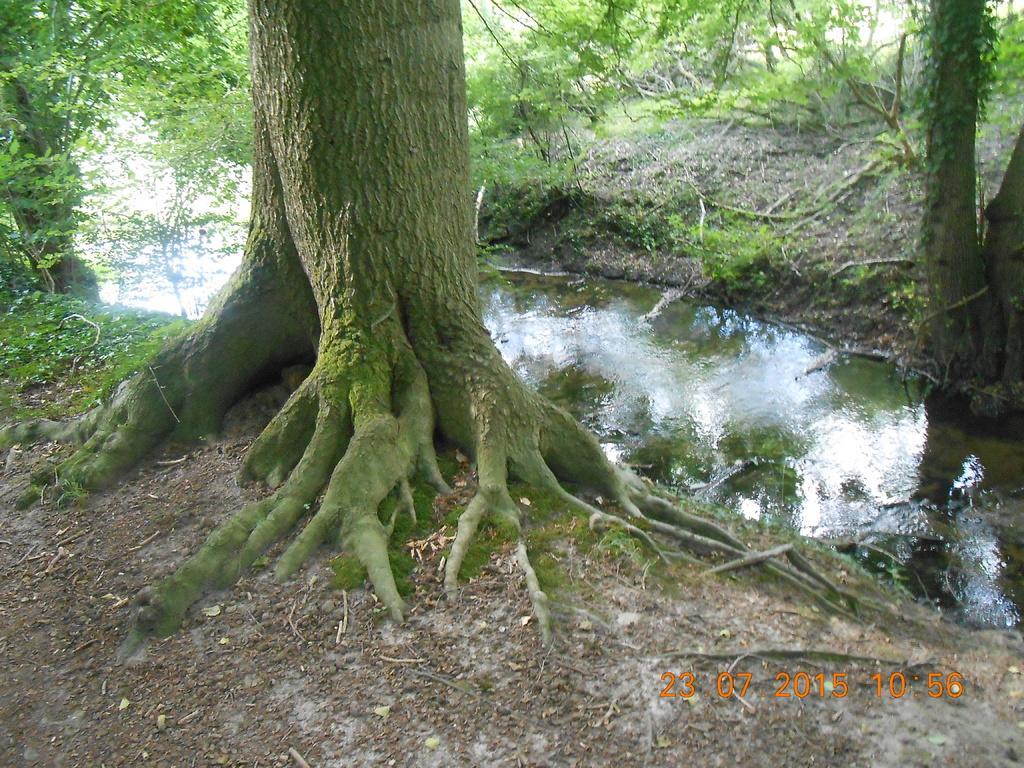Describe this image in one or two sentences. In the foreground of this image, there is a trunk at edges of the river. On the right side of the image, there is a tree and in the background, there are trees. 